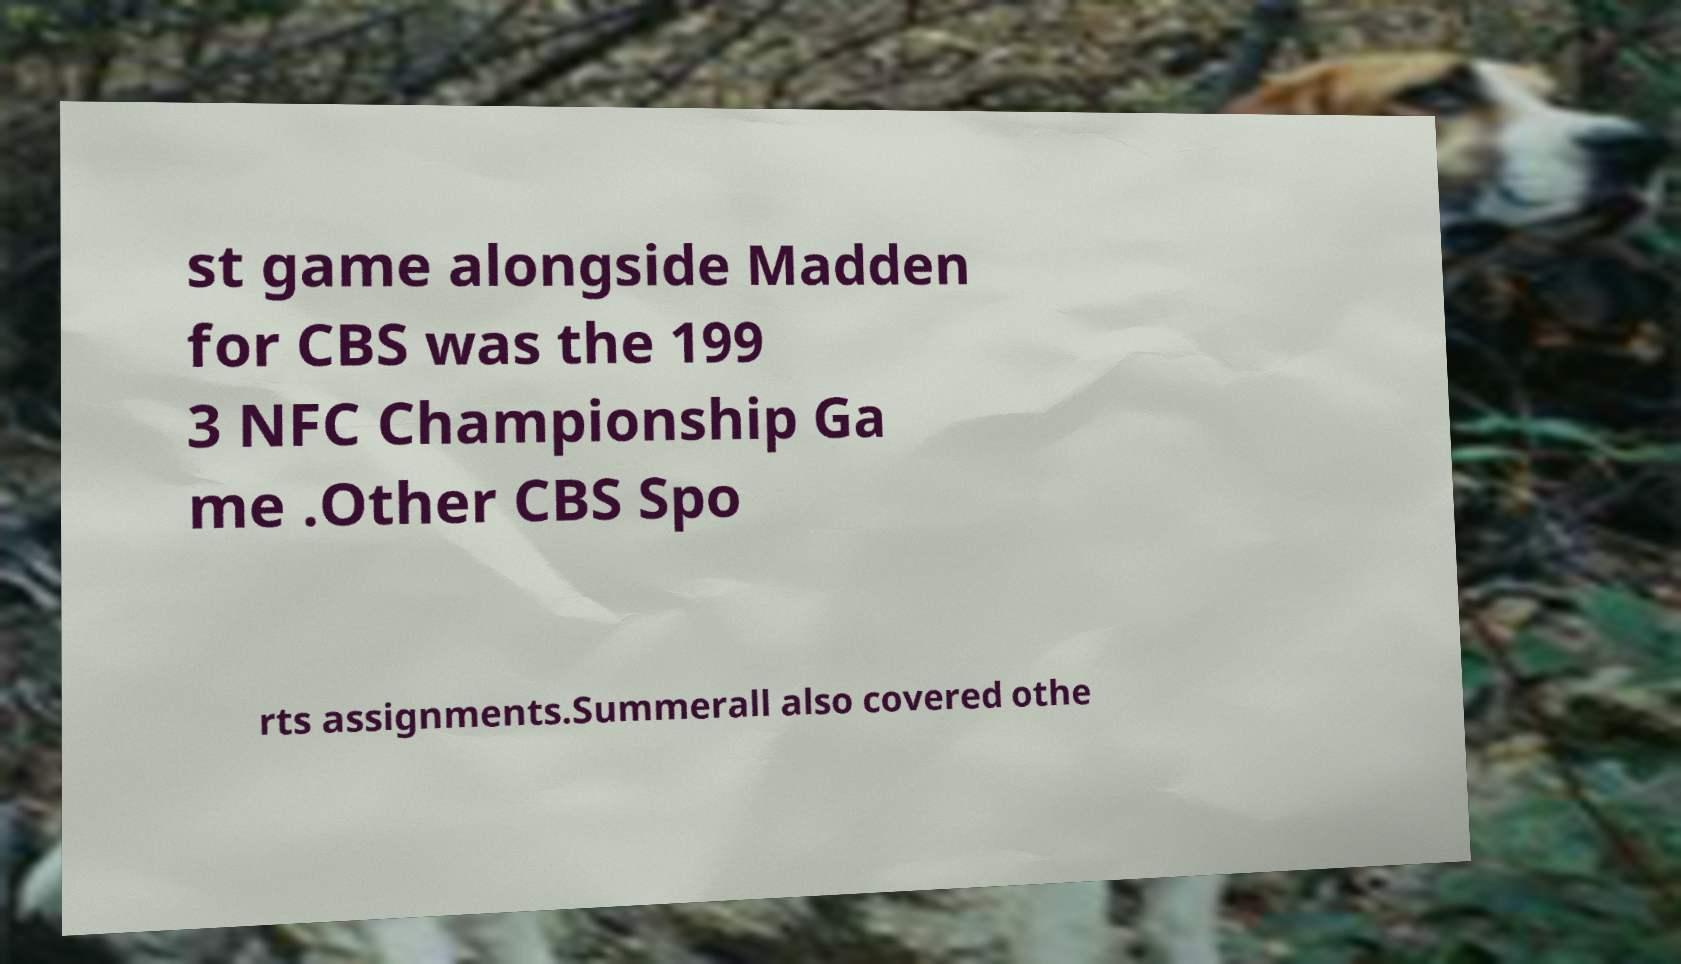Please read and relay the text visible in this image. What does it say? st game alongside Madden for CBS was the 199 3 NFC Championship Ga me .Other CBS Spo rts assignments.Summerall also covered othe 